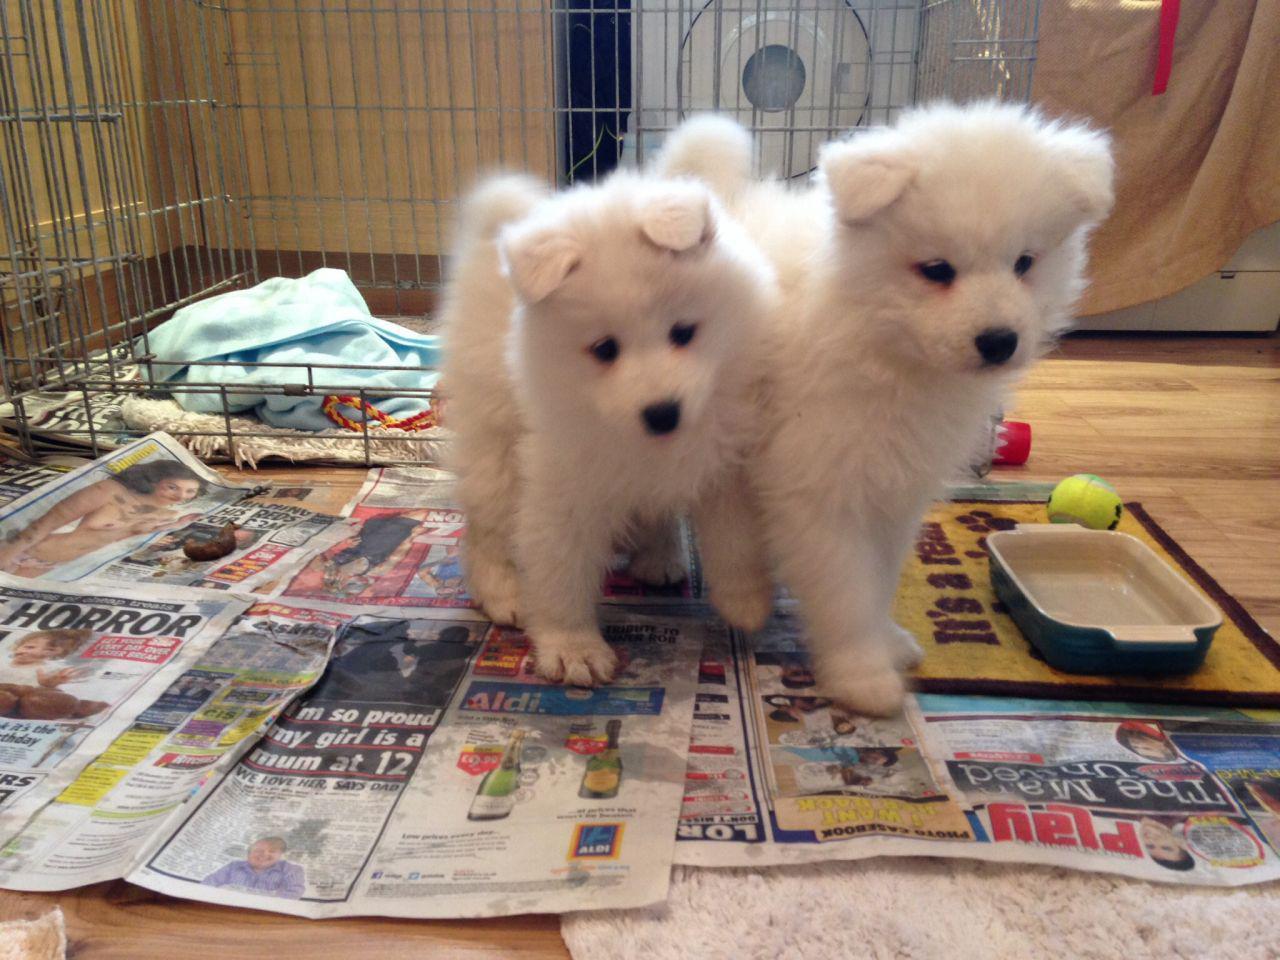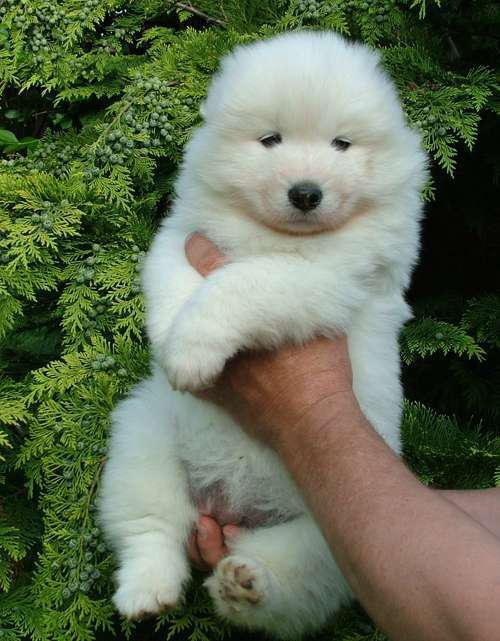The first image is the image on the left, the second image is the image on the right. For the images shown, is this caption "Hands are holding up at least five white puppies in one image." true? Answer yes or no. No. The first image is the image on the left, the second image is the image on the right. Given the left and right images, does the statement "There is no more than one white dog in the right image." hold true? Answer yes or no. Yes. 